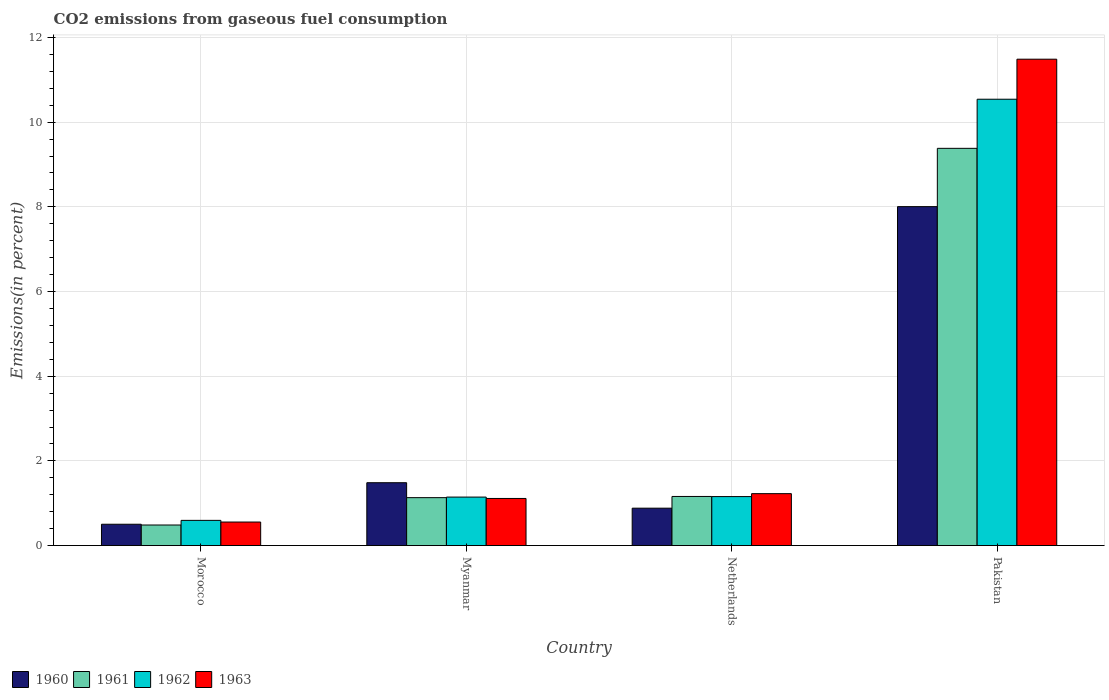How many different coloured bars are there?
Provide a short and direct response. 4. Are the number of bars per tick equal to the number of legend labels?
Make the answer very short. Yes. How many bars are there on the 2nd tick from the left?
Give a very brief answer. 4. How many bars are there on the 1st tick from the right?
Provide a short and direct response. 4. What is the label of the 4th group of bars from the left?
Provide a short and direct response. Pakistan. What is the total CO2 emitted in 1961 in Morocco?
Your response must be concise. 0.49. Across all countries, what is the maximum total CO2 emitted in 1960?
Keep it short and to the point. 8.01. Across all countries, what is the minimum total CO2 emitted in 1962?
Offer a terse response. 0.6. In which country was the total CO2 emitted in 1961 minimum?
Your answer should be very brief. Morocco. What is the total total CO2 emitted in 1963 in the graph?
Provide a short and direct response. 14.38. What is the difference between the total CO2 emitted in 1962 in Netherlands and that in Pakistan?
Offer a very short reply. -9.38. What is the difference between the total CO2 emitted in 1960 in Myanmar and the total CO2 emitted in 1962 in Morocco?
Give a very brief answer. 0.89. What is the average total CO2 emitted in 1962 per country?
Offer a very short reply. 3.36. What is the difference between the total CO2 emitted of/in 1961 and total CO2 emitted of/in 1962 in Netherlands?
Keep it short and to the point. 0. In how many countries, is the total CO2 emitted in 1961 greater than 7.2 %?
Provide a succinct answer. 1. What is the ratio of the total CO2 emitted in 1960 in Myanmar to that in Netherlands?
Offer a very short reply. 1.68. Is the difference between the total CO2 emitted in 1961 in Morocco and Myanmar greater than the difference between the total CO2 emitted in 1962 in Morocco and Myanmar?
Your answer should be very brief. No. What is the difference between the highest and the second highest total CO2 emitted in 1961?
Offer a very short reply. 8.25. What is the difference between the highest and the lowest total CO2 emitted in 1962?
Offer a very short reply. 9.95. Is it the case that in every country, the sum of the total CO2 emitted in 1961 and total CO2 emitted in 1962 is greater than the sum of total CO2 emitted in 1963 and total CO2 emitted in 1960?
Your answer should be compact. No. What does the 3rd bar from the left in Pakistan represents?
Your answer should be compact. 1962. Is it the case that in every country, the sum of the total CO2 emitted in 1960 and total CO2 emitted in 1962 is greater than the total CO2 emitted in 1961?
Ensure brevity in your answer.  Yes. How many bars are there?
Ensure brevity in your answer.  16. What is the difference between two consecutive major ticks on the Y-axis?
Your answer should be very brief. 2. Are the values on the major ticks of Y-axis written in scientific E-notation?
Ensure brevity in your answer.  No. Does the graph contain grids?
Make the answer very short. Yes. How are the legend labels stacked?
Give a very brief answer. Horizontal. What is the title of the graph?
Offer a very short reply. CO2 emissions from gaseous fuel consumption. What is the label or title of the X-axis?
Your response must be concise. Country. What is the label or title of the Y-axis?
Provide a succinct answer. Emissions(in percent). What is the Emissions(in percent) in 1960 in Morocco?
Offer a very short reply. 0.5. What is the Emissions(in percent) of 1961 in Morocco?
Ensure brevity in your answer.  0.49. What is the Emissions(in percent) in 1962 in Morocco?
Your response must be concise. 0.6. What is the Emissions(in percent) of 1963 in Morocco?
Make the answer very short. 0.56. What is the Emissions(in percent) of 1960 in Myanmar?
Offer a very short reply. 1.48. What is the Emissions(in percent) in 1961 in Myanmar?
Ensure brevity in your answer.  1.13. What is the Emissions(in percent) in 1962 in Myanmar?
Your response must be concise. 1.15. What is the Emissions(in percent) of 1963 in Myanmar?
Provide a short and direct response. 1.11. What is the Emissions(in percent) in 1960 in Netherlands?
Keep it short and to the point. 0.88. What is the Emissions(in percent) of 1961 in Netherlands?
Provide a short and direct response. 1.16. What is the Emissions(in percent) of 1962 in Netherlands?
Make the answer very short. 1.16. What is the Emissions(in percent) of 1963 in Netherlands?
Offer a terse response. 1.23. What is the Emissions(in percent) in 1960 in Pakistan?
Your answer should be compact. 8.01. What is the Emissions(in percent) of 1961 in Pakistan?
Keep it short and to the point. 9.38. What is the Emissions(in percent) in 1962 in Pakistan?
Your answer should be very brief. 10.54. What is the Emissions(in percent) of 1963 in Pakistan?
Provide a succinct answer. 11.49. Across all countries, what is the maximum Emissions(in percent) in 1960?
Offer a terse response. 8.01. Across all countries, what is the maximum Emissions(in percent) in 1961?
Provide a short and direct response. 9.38. Across all countries, what is the maximum Emissions(in percent) of 1962?
Your response must be concise. 10.54. Across all countries, what is the maximum Emissions(in percent) in 1963?
Provide a succinct answer. 11.49. Across all countries, what is the minimum Emissions(in percent) of 1960?
Your answer should be compact. 0.5. Across all countries, what is the minimum Emissions(in percent) in 1961?
Your response must be concise. 0.49. Across all countries, what is the minimum Emissions(in percent) in 1962?
Your answer should be very brief. 0.6. Across all countries, what is the minimum Emissions(in percent) of 1963?
Provide a succinct answer. 0.56. What is the total Emissions(in percent) of 1960 in the graph?
Make the answer very short. 10.88. What is the total Emissions(in percent) in 1961 in the graph?
Provide a succinct answer. 12.16. What is the total Emissions(in percent) in 1962 in the graph?
Keep it short and to the point. 13.44. What is the total Emissions(in percent) of 1963 in the graph?
Make the answer very short. 14.38. What is the difference between the Emissions(in percent) of 1960 in Morocco and that in Myanmar?
Offer a very short reply. -0.98. What is the difference between the Emissions(in percent) of 1961 in Morocco and that in Myanmar?
Ensure brevity in your answer.  -0.65. What is the difference between the Emissions(in percent) of 1962 in Morocco and that in Myanmar?
Ensure brevity in your answer.  -0.55. What is the difference between the Emissions(in percent) in 1963 in Morocco and that in Myanmar?
Give a very brief answer. -0.56. What is the difference between the Emissions(in percent) of 1960 in Morocco and that in Netherlands?
Your answer should be compact. -0.38. What is the difference between the Emissions(in percent) in 1961 in Morocco and that in Netherlands?
Ensure brevity in your answer.  -0.67. What is the difference between the Emissions(in percent) of 1962 in Morocco and that in Netherlands?
Provide a succinct answer. -0.56. What is the difference between the Emissions(in percent) of 1963 in Morocco and that in Netherlands?
Ensure brevity in your answer.  -0.67. What is the difference between the Emissions(in percent) in 1960 in Morocco and that in Pakistan?
Offer a very short reply. -7.5. What is the difference between the Emissions(in percent) of 1961 in Morocco and that in Pakistan?
Provide a short and direct response. -8.9. What is the difference between the Emissions(in percent) in 1962 in Morocco and that in Pakistan?
Your answer should be very brief. -9.95. What is the difference between the Emissions(in percent) in 1963 in Morocco and that in Pakistan?
Your answer should be very brief. -10.93. What is the difference between the Emissions(in percent) of 1960 in Myanmar and that in Netherlands?
Your response must be concise. 0.6. What is the difference between the Emissions(in percent) in 1961 in Myanmar and that in Netherlands?
Your answer should be very brief. -0.03. What is the difference between the Emissions(in percent) in 1962 in Myanmar and that in Netherlands?
Make the answer very short. -0.01. What is the difference between the Emissions(in percent) in 1963 in Myanmar and that in Netherlands?
Your answer should be very brief. -0.11. What is the difference between the Emissions(in percent) in 1960 in Myanmar and that in Pakistan?
Provide a succinct answer. -6.52. What is the difference between the Emissions(in percent) in 1961 in Myanmar and that in Pakistan?
Your response must be concise. -8.25. What is the difference between the Emissions(in percent) of 1962 in Myanmar and that in Pakistan?
Ensure brevity in your answer.  -9.4. What is the difference between the Emissions(in percent) of 1963 in Myanmar and that in Pakistan?
Give a very brief answer. -10.37. What is the difference between the Emissions(in percent) of 1960 in Netherlands and that in Pakistan?
Offer a very short reply. -7.12. What is the difference between the Emissions(in percent) in 1961 in Netherlands and that in Pakistan?
Provide a short and direct response. -8.22. What is the difference between the Emissions(in percent) of 1962 in Netherlands and that in Pakistan?
Provide a succinct answer. -9.38. What is the difference between the Emissions(in percent) of 1963 in Netherlands and that in Pakistan?
Your answer should be very brief. -10.26. What is the difference between the Emissions(in percent) of 1960 in Morocco and the Emissions(in percent) of 1961 in Myanmar?
Your response must be concise. -0.63. What is the difference between the Emissions(in percent) in 1960 in Morocco and the Emissions(in percent) in 1962 in Myanmar?
Keep it short and to the point. -0.64. What is the difference between the Emissions(in percent) in 1960 in Morocco and the Emissions(in percent) in 1963 in Myanmar?
Your response must be concise. -0.61. What is the difference between the Emissions(in percent) of 1961 in Morocco and the Emissions(in percent) of 1962 in Myanmar?
Your response must be concise. -0.66. What is the difference between the Emissions(in percent) in 1961 in Morocco and the Emissions(in percent) in 1963 in Myanmar?
Your answer should be very brief. -0.63. What is the difference between the Emissions(in percent) in 1962 in Morocco and the Emissions(in percent) in 1963 in Myanmar?
Keep it short and to the point. -0.52. What is the difference between the Emissions(in percent) in 1960 in Morocco and the Emissions(in percent) in 1961 in Netherlands?
Your response must be concise. -0.66. What is the difference between the Emissions(in percent) in 1960 in Morocco and the Emissions(in percent) in 1962 in Netherlands?
Provide a succinct answer. -0.65. What is the difference between the Emissions(in percent) in 1960 in Morocco and the Emissions(in percent) in 1963 in Netherlands?
Offer a very short reply. -0.72. What is the difference between the Emissions(in percent) of 1961 in Morocco and the Emissions(in percent) of 1962 in Netherlands?
Provide a short and direct response. -0.67. What is the difference between the Emissions(in percent) in 1961 in Morocco and the Emissions(in percent) in 1963 in Netherlands?
Provide a succinct answer. -0.74. What is the difference between the Emissions(in percent) in 1962 in Morocco and the Emissions(in percent) in 1963 in Netherlands?
Provide a short and direct response. -0.63. What is the difference between the Emissions(in percent) in 1960 in Morocco and the Emissions(in percent) in 1961 in Pakistan?
Offer a very short reply. -8.88. What is the difference between the Emissions(in percent) in 1960 in Morocco and the Emissions(in percent) in 1962 in Pakistan?
Keep it short and to the point. -10.04. What is the difference between the Emissions(in percent) in 1960 in Morocco and the Emissions(in percent) in 1963 in Pakistan?
Offer a terse response. -10.98. What is the difference between the Emissions(in percent) of 1961 in Morocco and the Emissions(in percent) of 1962 in Pakistan?
Make the answer very short. -10.06. What is the difference between the Emissions(in percent) in 1961 in Morocco and the Emissions(in percent) in 1963 in Pakistan?
Ensure brevity in your answer.  -11. What is the difference between the Emissions(in percent) of 1962 in Morocco and the Emissions(in percent) of 1963 in Pakistan?
Your answer should be compact. -10.89. What is the difference between the Emissions(in percent) of 1960 in Myanmar and the Emissions(in percent) of 1961 in Netherlands?
Make the answer very short. 0.32. What is the difference between the Emissions(in percent) in 1960 in Myanmar and the Emissions(in percent) in 1962 in Netherlands?
Offer a terse response. 0.33. What is the difference between the Emissions(in percent) in 1960 in Myanmar and the Emissions(in percent) in 1963 in Netherlands?
Your answer should be very brief. 0.26. What is the difference between the Emissions(in percent) of 1961 in Myanmar and the Emissions(in percent) of 1962 in Netherlands?
Provide a succinct answer. -0.03. What is the difference between the Emissions(in percent) in 1961 in Myanmar and the Emissions(in percent) in 1963 in Netherlands?
Give a very brief answer. -0.09. What is the difference between the Emissions(in percent) of 1962 in Myanmar and the Emissions(in percent) of 1963 in Netherlands?
Provide a short and direct response. -0.08. What is the difference between the Emissions(in percent) of 1960 in Myanmar and the Emissions(in percent) of 1961 in Pakistan?
Your response must be concise. -7.9. What is the difference between the Emissions(in percent) of 1960 in Myanmar and the Emissions(in percent) of 1962 in Pakistan?
Provide a short and direct response. -9.06. What is the difference between the Emissions(in percent) in 1960 in Myanmar and the Emissions(in percent) in 1963 in Pakistan?
Keep it short and to the point. -10. What is the difference between the Emissions(in percent) of 1961 in Myanmar and the Emissions(in percent) of 1962 in Pakistan?
Keep it short and to the point. -9.41. What is the difference between the Emissions(in percent) of 1961 in Myanmar and the Emissions(in percent) of 1963 in Pakistan?
Your answer should be compact. -10.36. What is the difference between the Emissions(in percent) of 1962 in Myanmar and the Emissions(in percent) of 1963 in Pakistan?
Your answer should be compact. -10.34. What is the difference between the Emissions(in percent) in 1960 in Netherlands and the Emissions(in percent) in 1961 in Pakistan?
Offer a very short reply. -8.5. What is the difference between the Emissions(in percent) in 1960 in Netherlands and the Emissions(in percent) in 1962 in Pakistan?
Give a very brief answer. -9.66. What is the difference between the Emissions(in percent) in 1960 in Netherlands and the Emissions(in percent) in 1963 in Pakistan?
Offer a terse response. -10.6. What is the difference between the Emissions(in percent) of 1961 in Netherlands and the Emissions(in percent) of 1962 in Pakistan?
Provide a succinct answer. -9.38. What is the difference between the Emissions(in percent) in 1961 in Netherlands and the Emissions(in percent) in 1963 in Pakistan?
Make the answer very short. -10.33. What is the difference between the Emissions(in percent) in 1962 in Netherlands and the Emissions(in percent) in 1963 in Pakistan?
Provide a short and direct response. -10.33. What is the average Emissions(in percent) of 1960 per country?
Provide a short and direct response. 2.72. What is the average Emissions(in percent) of 1961 per country?
Make the answer very short. 3.04. What is the average Emissions(in percent) in 1962 per country?
Make the answer very short. 3.36. What is the average Emissions(in percent) of 1963 per country?
Keep it short and to the point. 3.6. What is the difference between the Emissions(in percent) in 1960 and Emissions(in percent) in 1961 in Morocco?
Your response must be concise. 0.02. What is the difference between the Emissions(in percent) in 1960 and Emissions(in percent) in 1962 in Morocco?
Provide a short and direct response. -0.09. What is the difference between the Emissions(in percent) in 1960 and Emissions(in percent) in 1963 in Morocco?
Give a very brief answer. -0.05. What is the difference between the Emissions(in percent) in 1961 and Emissions(in percent) in 1962 in Morocco?
Your answer should be very brief. -0.11. What is the difference between the Emissions(in percent) in 1961 and Emissions(in percent) in 1963 in Morocco?
Give a very brief answer. -0.07. What is the difference between the Emissions(in percent) of 1962 and Emissions(in percent) of 1963 in Morocco?
Your answer should be compact. 0.04. What is the difference between the Emissions(in percent) in 1960 and Emissions(in percent) in 1961 in Myanmar?
Your answer should be very brief. 0.35. What is the difference between the Emissions(in percent) of 1960 and Emissions(in percent) of 1962 in Myanmar?
Provide a short and direct response. 0.34. What is the difference between the Emissions(in percent) of 1960 and Emissions(in percent) of 1963 in Myanmar?
Provide a short and direct response. 0.37. What is the difference between the Emissions(in percent) in 1961 and Emissions(in percent) in 1962 in Myanmar?
Make the answer very short. -0.01. What is the difference between the Emissions(in percent) of 1961 and Emissions(in percent) of 1963 in Myanmar?
Provide a succinct answer. 0.02. What is the difference between the Emissions(in percent) of 1962 and Emissions(in percent) of 1963 in Myanmar?
Provide a short and direct response. 0.03. What is the difference between the Emissions(in percent) in 1960 and Emissions(in percent) in 1961 in Netherlands?
Keep it short and to the point. -0.28. What is the difference between the Emissions(in percent) of 1960 and Emissions(in percent) of 1962 in Netherlands?
Make the answer very short. -0.27. What is the difference between the Emissions(in percent) of 1960 and Emissions(in percent) of 1963 in Netherlands?
Offer a terse response. -0.34. What is the difference between the Emissions(in percent) of 1961 and Emissions(in percent) of 1962 in Netherlands?
Your answer should be very brief. 0. What is the difference between the Emissions(in percent) of 1961 and Emissions(in percent) of 1963 in Netherlands?
Make the answer very short. -0.07. What is the difference between the Emissions(in percent) of 1962 and Emissions(in percent) of 1963 in Netherlands?
Give a very brief answer. -0.07. What is the difference between the Emissions(in percent) of 1960 and Emissions(in percent) of 1961 in Pakistan?
Make the answer very short. -1.38. What is the difference between the Emissions(in percent) of 1960 and Emissions(in percent) of 1962 in Pakistan?
Offer a very short reply. -2.54. What is the difference between the Emissions(in percent) of 1960 and Emissions(in percent) of 1963 in Pakistan?
Offer a very short reply. -3.48. What is the difference between the Emissions(in percent) of 1961 and Emissions(in percent) of 1962 in Pakistan?
Your answer should be very brief. -1.16. What is the difference between the Emissions(in percent) in 1961 and Emissions(in percent) in 1963 in Pakistan?
Make the answer very short. -2.11. What is the difference between the Emissions(in percent) in 1962 and Emissions(in percent) in 1963 in Pakistan?
Offer a very short reply. -0.95. What is the ratio of the Emissions(in percent) of 1960 in Morocco to that in Myanmar?
Offer a terse response. 0.34. What is the ratio of the Emissions(in percent) in 1961 in Morocco to that in Myanmar?
Offer a terse response. 0.43. What is the ratio of the Emissions(in percent) in 1962 in Morocco to that in Myanmar?
Offer a very short reply. 0.52. What is the ratio of the Emissions(in percent) in 1963 in Morocco to that in Myanmar?
Provide a succinct answer. 0.5. What is the ratio of the Emissions(in percent) in 1960 in Morocco to that in Netherlands?
Give a very brief answer. 0.57. What is the ratio of the Emissions(in percent) in 1961 in Morocco to that in Netherlands?
Provide a succinct answer. 0.42. What is the ratio of the Emissions(in percent) of 1962 in Morocco to that in Netherlands?
Provide a short and direct response. 0.51. What is the ratio of the Emissions(in percent) of 1963 in Morocco to that in Netherlands?
Your answer should be compact. 0.45. What is the ratio of the Emissions(in percent) of 1960 in Morocco to that in Pakistan?
Your response must be concise. 0.06. What is the ratio of the Emissions(in percent) of 1961 in Morocco to that in Pakistan?
Give a very brief answer. 0.05. What is the ratio of the Emissions(in percent) of 1962 in Morocco to that in Pakistan?
Provide a succinct answer. 0.06. What is the ratio of the Emissions(in percent) in 1963 in Morocco to that in Pakistan?
Your answer should be compact. 0.05. What is the ratio of the Emissions(in percent) of 1960 in Myanmar to that in Netherlands?
Your response must be concise. 1.68. What is the ratio of the Emissions(in percent) of 1961 in Myanmar to that in Netherlands?
Keep it short and to the point. 0.98. What is the ratio of the Emissions(in percent) of 1963 in Myanmar to that in Netherlands?
Provide a short and direct response. 0.91. What is the ratio of the Emissions(in percent) of 1960 in Myanmar to that in Pakistan?
Keep it short and to the point. 0.19. What is the ratio of the Emissions(in percent) of 1961 in Myanmar to that in Pakistan?
Offer a very short reply. 0.12. What is the ratio of the Emissions(in percent) in 1962 in Myanmar to that in Pakistan?
Provide a succinct answer. 0.11. What is the ratio of the Emissions(in percent) of 1963 in Myanmar to that in Pakistan?
Your response must be concise. 0.1. What is the ratio of the Emissions(in percent) in 1960 in Netherlands to that in Pakistan?
Give a very brief answer. 0.11. What is the ratio of the Emissions(in percent) in 1961 in Netherlands to that in Pakistan?
Make the answer very short. 0.12. What is the ratio of the Emissions(in percent) of 1962 in Netherlands to that in Pakistan?
Give a very brief answer. 0.11. What is the ratio of the Emissions(in percent) in 1963 in Netherlands to that in Pakistan?
Offer a very short reply. 0.11. What is the difference between the highest and the second highest Emissions(in percent) in 1960?
Provide a succinct answer. 6.52. What is the difference between the highest and the second highest Emissions(in percent) of 1961?
Your answer should be compact. 8.22. What is the difference between the highest and the second highest Emissions(in percent) in 1962?
Offer a terse response. 9.38. What is the difference between the highest and the second highest Emissions(in percent) in 1963?
Provide a succinct answer. 10.26. What is the difference between the highest and the lowest Emissions(in percent) of 1960?
Make the answer very short. 7.5. What is the difference between the highest and the lowest Emissions(in percent) in 1961?
Keep it short and to the point. 8.9. What is the difference between the highest and the lowest Emissions(in percent) in 1962?
Provide a succinct answer. 9.95. What is the difference between the highest and the lowest Emissions(in percent) in 1963?
Your answer should be compact. 10.93. 